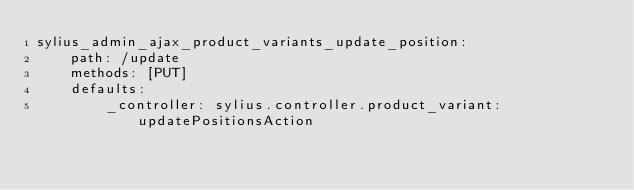<code> <loc_0><loc_0><loc_500><loc_500><_YAML_>sylius_admin_ajax_product_variants_update_position:
    path: /update
    methods: [PUT]
    defaults:
        _controller: sylius.controller.product_variant:updatePositionsAction
</code> 